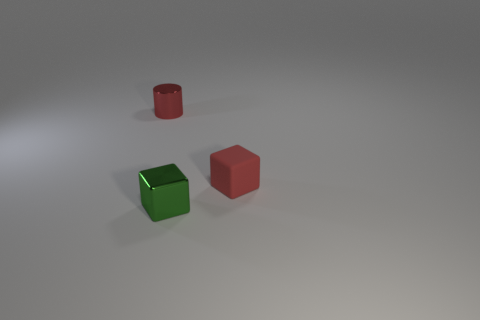Subtract all cylinders. How many objects are left? 2 Add 2 small green shiny blocks. How many objects exist? 5 Subtract all small cylinders. Subtract all small red metal things. How many objects are left? 1 Add 1 green shiny objects. How many green shiny objects are left? 2 Add 3 blue rubber blocks. How many blue rubber blocks exist? 3 Subtract 1 green cubes. How many objects are left? 2 